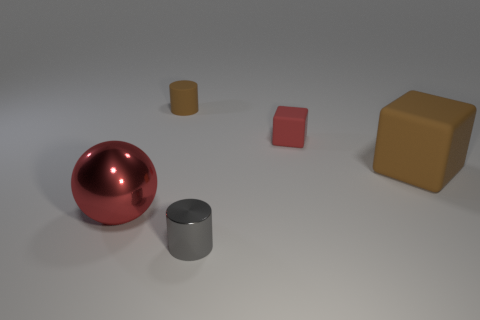Add 3 small brown cylinders. How many objects exist? 8 Subtract all cylinders. How many objects are left? 3 Subtract 0 yellow cylinders. How many objects are left? 5 Subtract all cylinders. Subtract all tiny objects. How many objects are left? 0 Add 5 big brown rubber cubes. How many big brown rubber cubes are left? 6 Add 3 tiny yellow blocks. How many tiny yellow blocks exist? 3 